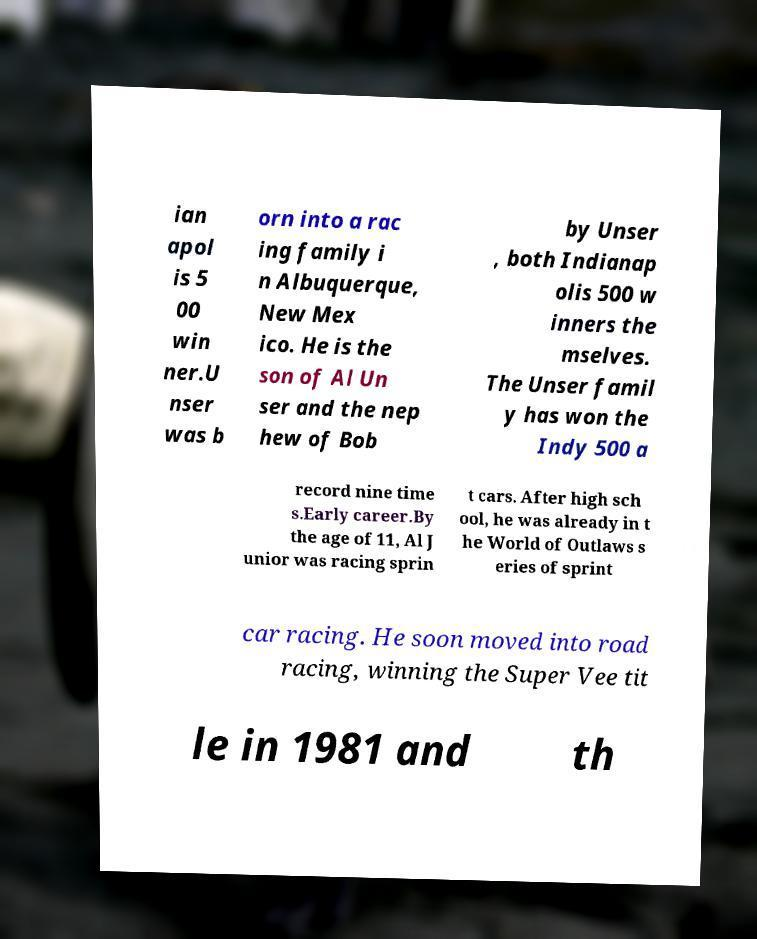Please read and relay the text visible in this image. What does it say? ian apol is 5 00 win ner.U nser was b orn into a rac ing family i n Albuquerque, New Mex ico. He is the son of Al Un ser and the nep hew of Bob by Unser , both Indianap olis 500 w inners the mselves. The Unser famil y has won the Indy 500 a record nine time s.Early career.By the age of 11, Al J unior was racing sprin t cars. After high sch ool, he was already in t he World of Outlaws s eries of sprint car racing. He soon moved into road racing, winning the Super Vee tit le in 1981 and th 